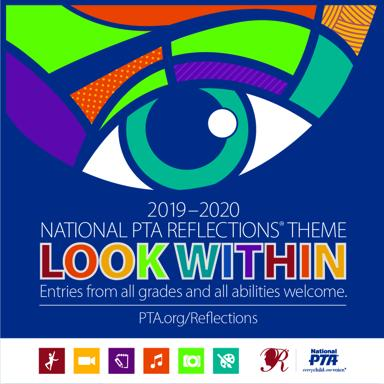Can you describe what visual elements on the poster symbolize the theme 'Look Within'? The poster features an eye in vibrant colors, symbolizing introspection and self-examination, directly reflecting the theme 'Look Within'. The abstract design around the eye suggests creativity and the exploration of one’s inner world through art. 